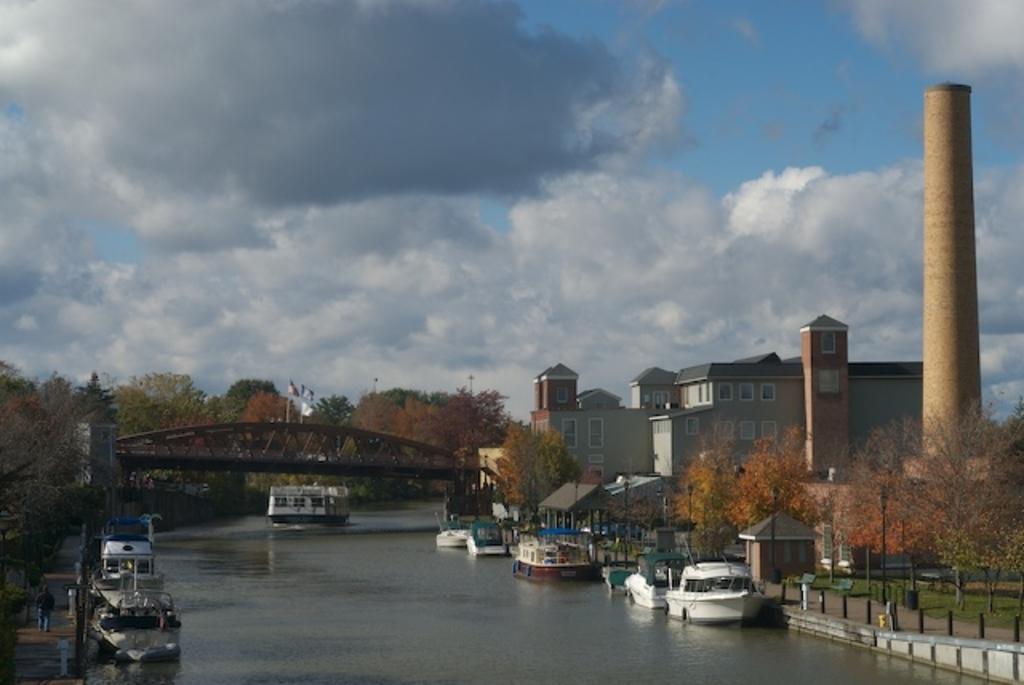Describe this image in one or two sentences. In the foreground, I can see fleets of boats in the water and I can see a fence, grass, light poles, trees and a group of people on the road. In the background, I can see buildings, bridge, flagpoles, pillar and the sky. This picture might be taken in a day. 